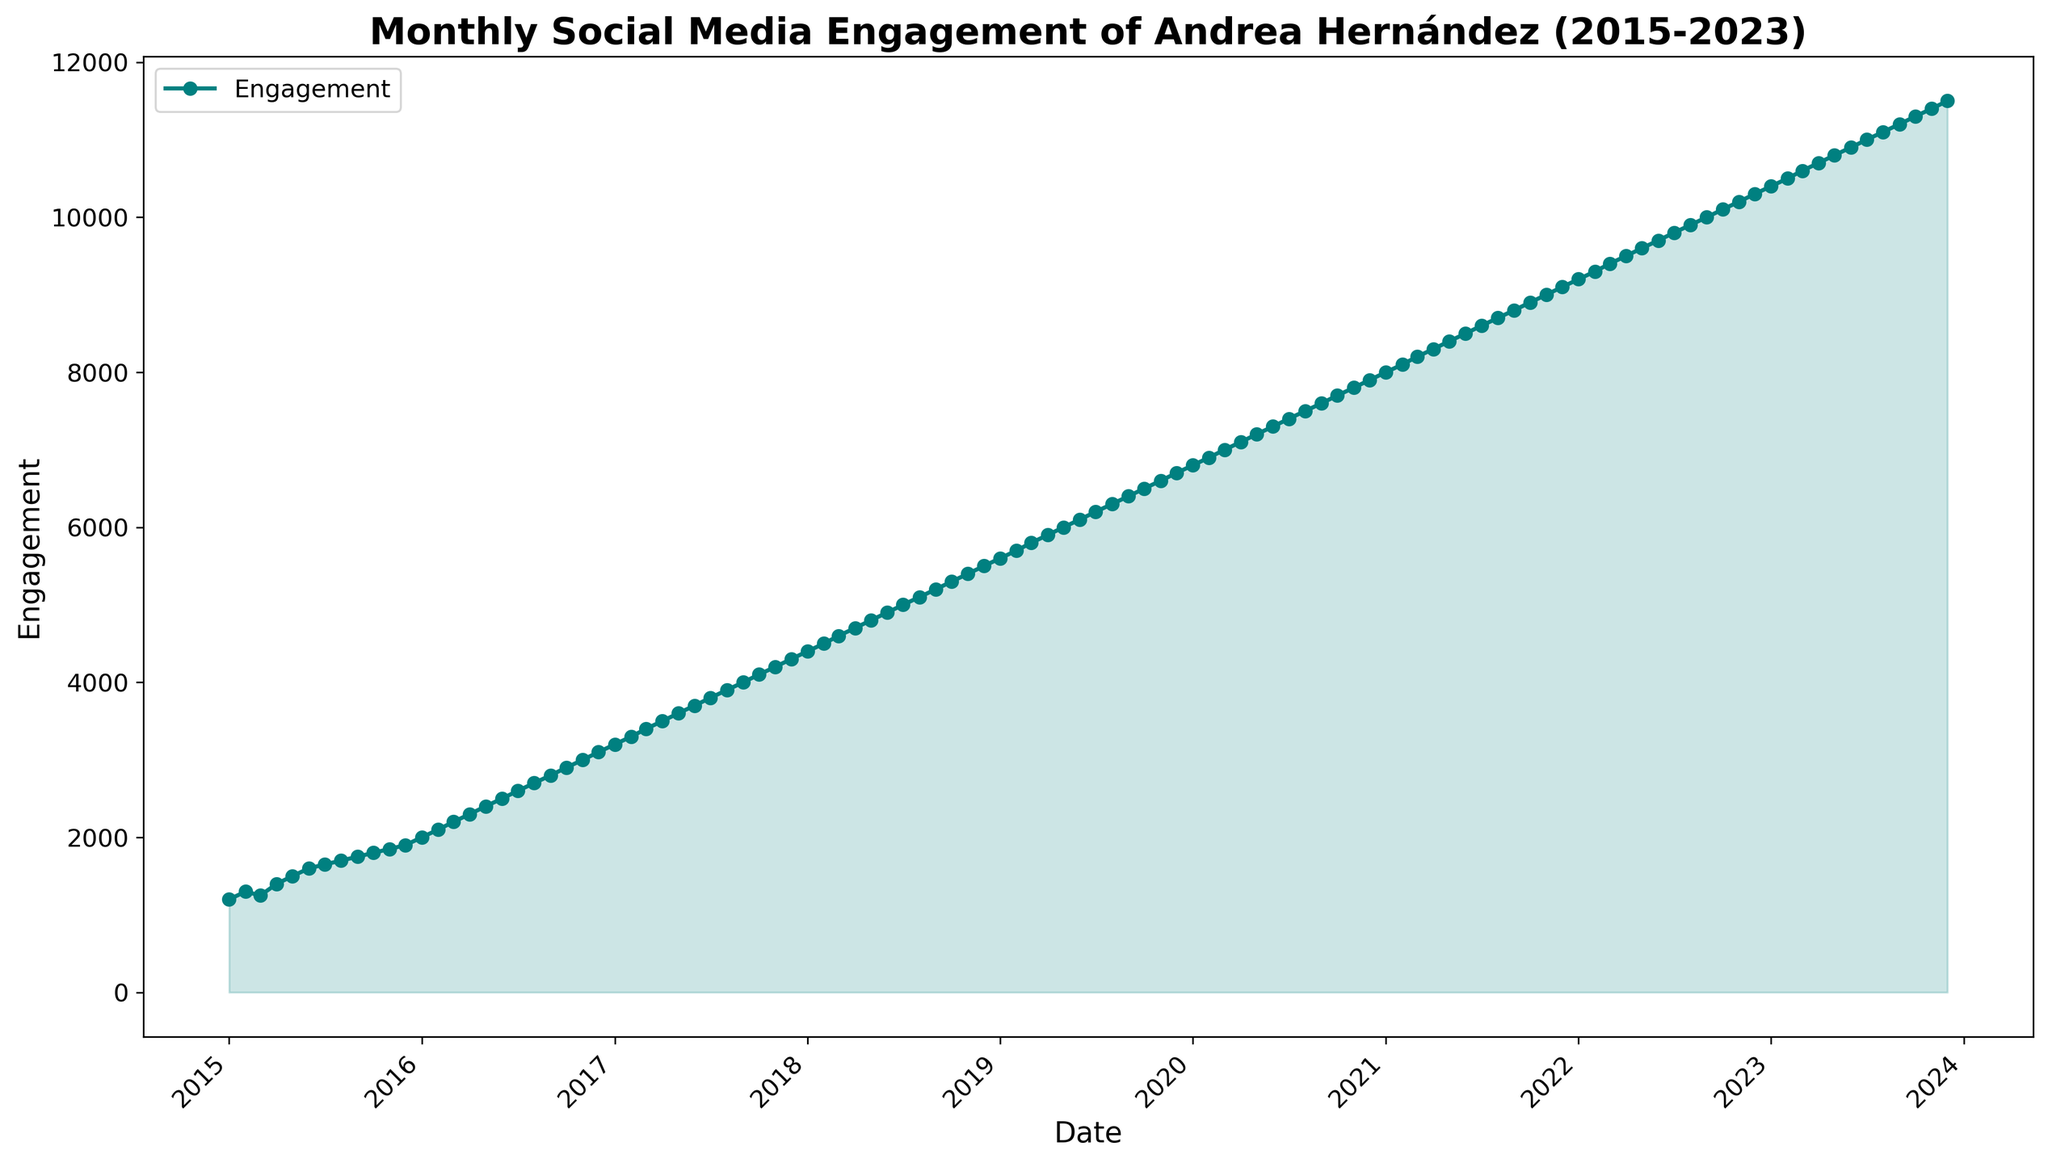1. What is the highest engagement level reached by Andrea Hernández from 2015 to 2023? The highest point on the chart, where the line reaches the peak and the fill area ends at the top, represents the maximum engagement level. From the figure, the highest engagement level is reached in December 2023.
Answer: 11500 2. How did Andrea Hernández's monthly social media engagement change between January 2017 and January 2018? To determine the change, compare the engagement values at these two points. In January 2017, the engagement was 3200, and in January 2018, it was 4400. Subtract the January 2017 value from the January 2018 value: 4400 - 3200 = 1200
Answer: Increased by 1200 3. Which year experienced the most significant increase in engagement from January to December? To find the year with the largest increase, check the engagement values in January and December for each year and compute the differences. Identifying the largest difference will reveal the year with the most significant increase. The year 2017 had the largest difference: December 2017 (4300) - January 2017 (3200) = 1100.
Answer: 2017 4. By how much did Andrea Hernández's engagement increase from January 2015 to January 2016? Compare the engagement values in January 2015 (1200) and January 2016 (2000). Subtract the January 2015 value from the January 2016 value: 2000 - 1200 = 800
Answer: 800 5. What is the average monthly engagement in 2020? Sum all monthly engagement values in 2020 and divide by 12. The values from January to December 2020 are: 6800, 6900, 7000, 7100, 7200, 7300, 7400, 7500, 7600, 7700, 7800, and 7900. Summing them gives 88700, and dividing by 12 results in 88700 / 12 ≈ 7391.67
Answer: 7391.67 6. During which month in 2023 did engagement first exceed 11000? Observe the x-axis and corresponding engagement line in 2023. The engagement first exceeds 11000 in July 2023.
Answer: July 7. How does engagement in December 2023 compare to engagement in December 2022? Compare the engagement values directly. In December 2022, engagement is 10300. In December 2023, it is 11500. Subtract to find the difference: 11500 - 10300 = 1200.
Answer: Increased by 1200 8. What kind of visual trend is noticeable in Andrea Hernández's engagement from 2015 to 2023? Observing the overall shape and direction of the line and filled area, it continuously rises without significant dips, indicating a steady upward trend in engagement.
Answer: Steady upward trend 